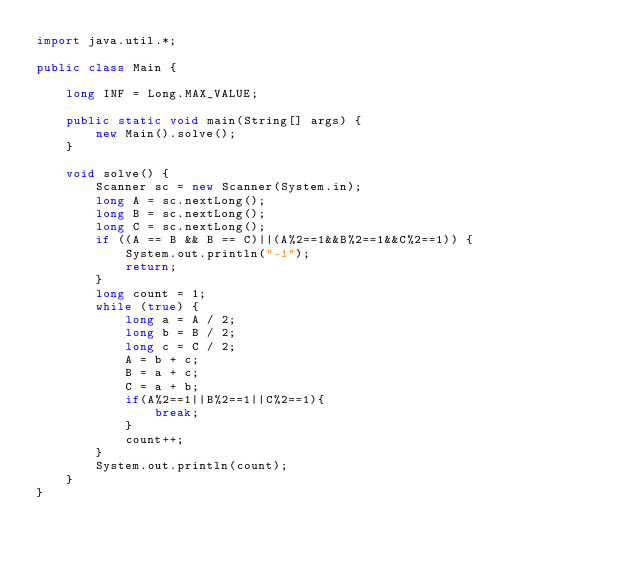Convert code to text. <code><loc_0><loc_0><loc_500><loc_500><_Java_>import java.util.*;

public class Main {

    long INF = Long.MAX_VALUE;

    public static void main(String[] args) {
        new Main().solve();
    }

    void solve() {
        Scanner sc = new Scanner(System.in);
        long A = sc.nextLong();
        long B = sc.nextLong();
        long C = sc.nextLong();
        if ((A == B && B == C)||(A%2==1&&B%2==1&&C%2==1)) {
            System.out.println("-1");
            return;
        }
        long count = 1;
        while (true) {
            long a = A / 2;
            long b = B / 2;
            long c = C / 2;
            A = b + c;
            B = a + c;
            C = a + b;
            if(A%2==1||B%2==1||C%2==1){
                break;
            }
            count++;
        }
        System.out.println(count);
    }
}</code> 